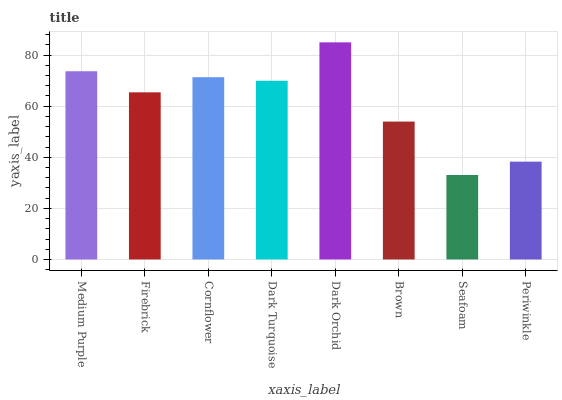Is Firebrick the minimum?
Answer yes or no. No. Is Firebrick the maximum?
Answer yes or no. No. Is Medium Purple greater than Firebrick?
Answer yes or no. Yes. Is Firebrick less than Medium Purple?
Answer yes or no. Yes. Is Firebrick greater than Medium Purple?
Answer yes or no. No. Is Medium Purple less than Firebrick?
Answer yes or no. No. Is Dark Turquoise the high median?
Answer yes or no. Yes. Is Firebrick the low median?
Answer yes or no. Yes. Is Periwinkle the high median?
Answer yes or no. No. Is Medium Purple the low median?
Answer yes or no. No. 